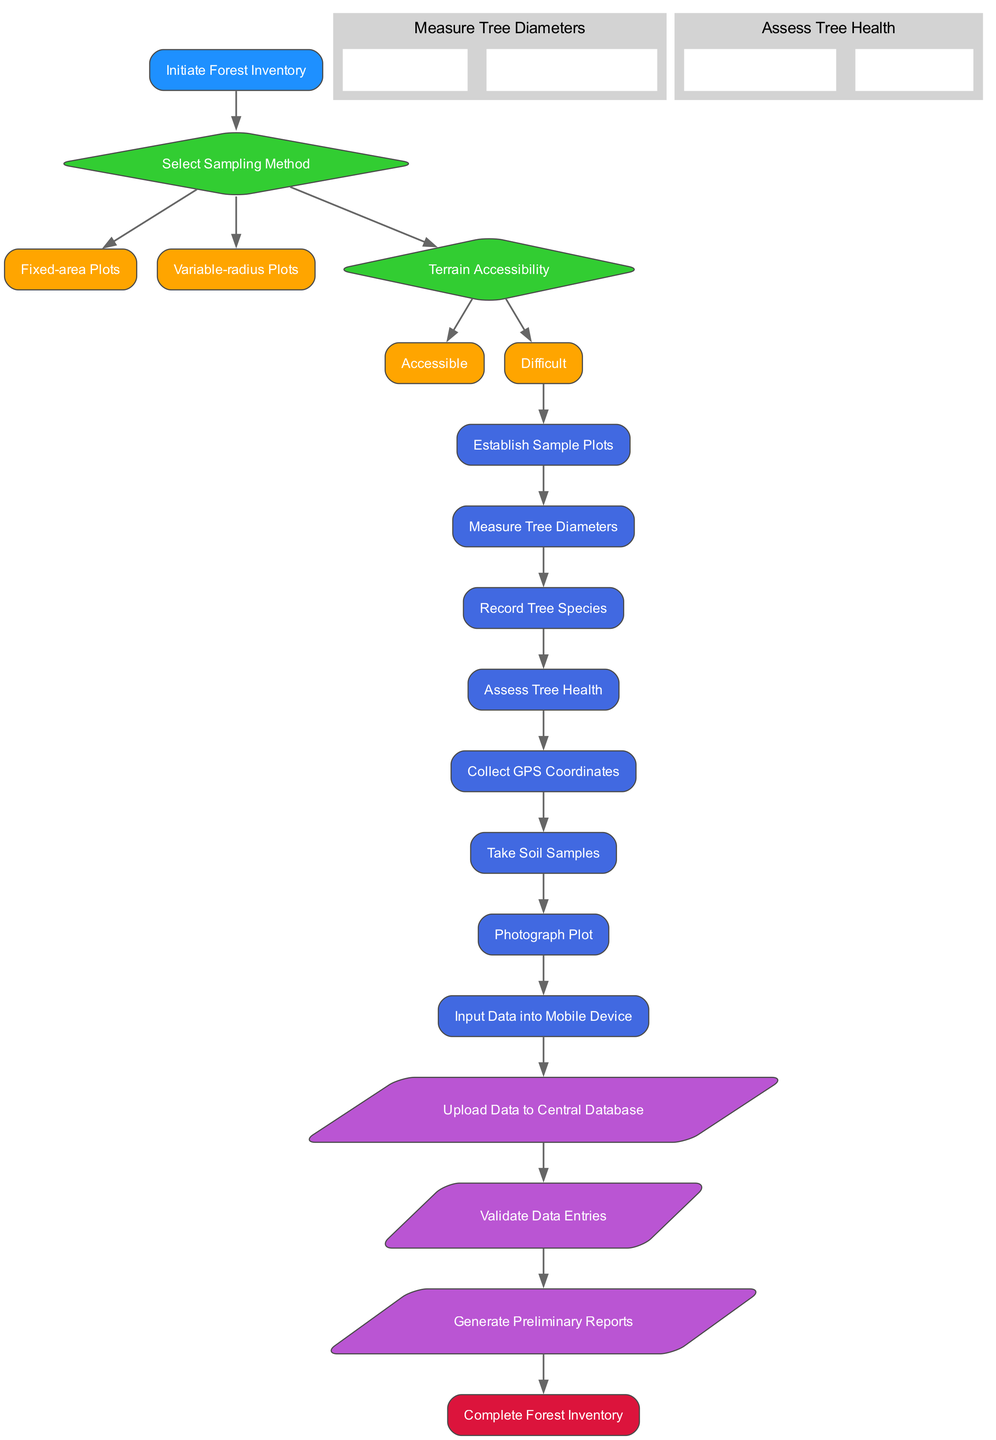What is the first process in the flow chart? The flow chart starts with the 'Initiate Forest Inventory' node, followed by the decision nodes. The first process that follows the initial decision is 'Establish Sample Plots'.
Answer: Establish Sample Plots How many sampling methods are presented in the diagram? The diagram presents two sampling methods under the decision node 'Select Sampling Method', which are 'Fixed-area Plots' and 'Variable-radius Plots'.
Answer: Two What happens if the terrain is difficult? If the terrain is classified as 'Difficult', the flow would follow the designated paths that ultimately lead to establishing sample plots, measuring diameters, and so on — essentially following the process but the specifics tied to terrain accessibility may influence later steps. However, the flow still goes through 'Establish Sample Plots' as the first process.
Answer: Establish Sample Plots How many subprocesses are associated with measuring tree diameters? There is one subprocess connected to the process of measuring tree diameters, which includes the steps 'Use DBH Tape' and 'Record Measurements'.
Answer: One Which step requires inputting data into a mobile device? The step that involves the use of a mobile device specifically states 'Input Data into Mobile Device', which is a designated process in the diagram right before uploading to the central database.
Answer: Input Data into Mobile Device What type of nodes represent data flows in the diagram? The data flow nodes are represented as parallelograms, which are typically used in flow charts to signify inputs and outputs or data-related activities.
Answer: Parallelograms What is the final output of the flow chart process? The last node in the flow chart denotes the end of the process, labeled as 'Complete Forest Inventory', which signifies that the overall inventory task is finalized.
Answer: Complete Forest Inventory How does the flow progress after 'Collect GPS Coordinates'? After 'Collect GPS Coordinates', the next process in the flow is 'Take Soil Samples', indicating a straightforward progression along the established series of steps in the forest inventory process.
Answer: Take Soil Samples How many edges connect the decision nodes to their options? Each decision node connects to its respective options — the first decision node has two options, and the second decision node does as well. In total, there are four edges connecting the decision nodes to their options.
Answer: Four 